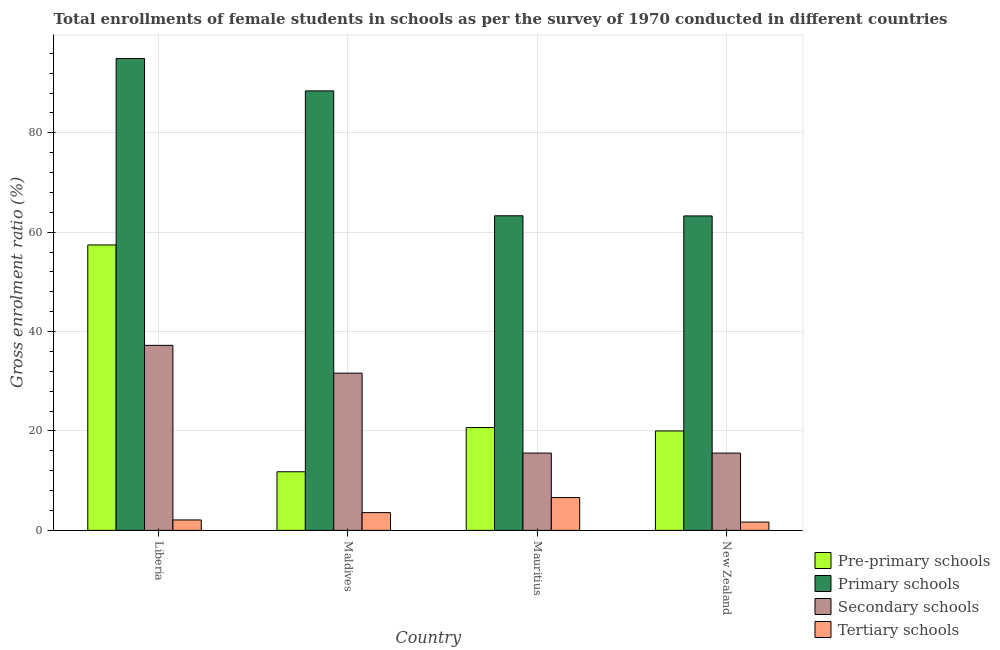How many groups of bars are there?
Your response must be concise. 4. How many bars are there on the 1st tick from the left?
Your response must be concise. 4. How many bars are there on the 3rd tick from the right?
Your answer should be very brief. 4. What is the label of the 4th group of bars from the left?
Provide a succinct answer. New Zealand. What is the gross enrolment ratio(female) in pre-primary schools in Liberia?
Ensure brevity in your answer.  57.43. Across all countries, what is the maximum gross enrolment ratio(female) in pre-primary schools?
Give a very brief answer. 57.43. Across all countries, what is the minimum gross enrolment ratio(female) in tertiary schools?
Your answer should be very brief. 1.67. In which country was the gross enrolment ratio(female) in primary schools maximum?
Your response must be concise. Liberia. In which country was the gross enrolment ratio(female) in pre-primary schools minimum?
Give a very brief answer. Maldives. What is the total gross enrolment ratio(female) in pre-primary schools in the graph?
Give a very brief answer. 109.93. What is the difference between the gross enrolment ratio(female) in tertiary schools in Liberia and that in Maldives?
Provide a short and direct response. -1.47. What is the difference between the gross enrolment ratio(female) in primary schools in New Zealand and the gross enrolment ratio(female) in secondary schools in Liberia?
Your answer should be compact. 26.04. What is the average gross enrolment ratio(female) in primary schools per country?
Give a very brief answer. 77.49. What is the difference between the gross enrolment ratio(female) in secondary schools and gross enrolment ratio(female) in primary schools in Maldives?
Your answer should be compact. -56.8. In how many countries, is the gross enrolment ratio(female) in tertiary schools greater than 28 %?
Your response must be concise. 0. What is the ratio of the gross enrolment ratio(female) in pre-primary schools in Liberia to that in Maldives?
Offer a terse response. 4.87. Is the gross enrolment ratio(female) in tertiary schools in Liberia less than that in New Zealand?
Offer a terse response. No. Is the difference between the gross enrolment ratio(female) in tertiary schools in Liberia and Maldives greater than the difference between the gross enrolment ratio(female) in pre-primary schools in Liberia and Maldives?
Ensure brevity in your answer.  No. What is the difference between the highest and the second highest gross enrolment ratio(female) in secondary schools?
Ensure brevity in your answer.  5.59. What is the difference between the highest and the lowest gross enrolment ratio(female) in secondary schools?
Give a very brief answer. 21.68. In how many countries, is the gross enrolment ratio(female) in tertiary schools greater than the average gross enrolment ratio(female) in tertiary schools taken over all countries?
Your answer should be compact. 2. What does the 3rd bar from the left in New Zealand represents?
Provide a short and direct response. Secondary schools. What does the 3rd bar from the right in Mauritius represents?
Ensure brevity in your answer.  Primary schools. Is it the case that in every country, the sum of the gross enrolment ratio(female) in pre-primary schools and gross enrolment ratio(female) in primary schools is greater than the gross enrolment ratio(female) in secondary schools?
Provide a short and direct response. Yes. How many bars are there?
Keep it short and to the point. 16. How many countries are there in the graph?
Your answer should be compact. 4. What is the difference between two consecutive major ticks on the Y-axis?
Offer a terse response. 20. Are the values on the major ticks of Y-axis written in scientific E-notation?
Your response must be concise. No. Where does the legend appear in the graph?
Ensure brevity in your answer.  Bottom right. How are the legend labels stacked?
Keep it short and to the point. Vertical. What is the title of the graph?
Provide a short and direct response. Total enrollments of female students in schools as per the survey of 1970 conducted in different countries. What is the label or title of the X-axis?
Your answer should be compact. Country. What is the Gross enrolment ratio (%) of Pre-primary schools in Liberia?
Your answer should be compact. 57.43. What is the Gross enrolment ratio (%) in Primary schools in Liberia?
Offer a very short reply. 94.95. What is the Gross enrolment ratio (%) of Secondary schools in Liberia?
Your response must be concise. 37.23. What is the Gross enrolment ratio (%) of Tertiary schools in Liberia?
Give a very brief answer. 2.1. What is the Gross enrolment ratio (%) in Pre-primary schools in Maldives?
Your answer should be compact. 11.8. What is the Gross enrolment ratio (%) in Primary schools in Maldives?
Offer a very short reply. 88.43. What is the Gross enrolment ratio (%) of Secondary schools in Maldives?
Make the answer very short. 31.64. What is the Gross enrolment ratio (%) of Tertiary schools in Maldives?
Offer a very short reply. 3.58. What is the Gross enrolment ratio (%) in Pre-primary schools in Mauritius?
Provide a succinct answer. 20.69. What is the Gross enrolment ratio (%) in Primary schools in Mauritius?
Your answer should be compact. 63.3. What is the Gross enrolment ratio (%) in Secondary schools in Mauritius?
Make the answer very short. 15.56. What is the Gross enrolment ratio (%) in Tertiary schools in Mauritius?
Your response must be concise. 6.6. What is the Gross enrolment ratio (%) of Pre-primary schools in New Zealand?
Ensure brevity in your answer.  20.01. What is the Gross enrolment ratio (%) in Primary schools in New Zealand?
Provide a succinct answer. 63.27. What is the Gross enrolment ratio (%) of Secondary schools in New Zealand?
Keep it short and to the point. 15.55. What is the Gross enrolment ratio (%) in Tertiary schools in New Zealand?
Your answer should be very brief. 1.67. Across all countries, what is the maximum Gross enrolment ratio (%) of Pre-primary schools?
Your answer should be compact. 57.43. Across all countries, what is the maximum Gross enrolment ratio (%) in Primary schools?
Your response must be concise. 94.95. Across all countries, what is the maximum Gross enrolment ratio (%) in Secondary schools?
Ensure brevity in your answer.  37.23. Across all countries, what is the maximum Gross enrolment ratio (%) of Tertiary schools?
Provide a succinct answer. 6.6. Across all countries, what is the minimum Gross enrolment ratio (%) of Pre-primary schools?
Ensure brevity in your answer.  11.8. Across all countries, what is the minimum Gross enrolment ratio (%) of Primary schools?
Provide a short and direct response. 63.27. Across all countries, what is the minimum Gross enrolment ratio (%) in Secondary schools?
Ensure brevity in your answer.  15.55. Across all countries, what is the minimum Gross enrolment ratio (%) in Tertiary schools?
Your answer should be compact. 1.67. What is the total Gross enrolment ratio (%) of Pre-primary schools in the graph?
Keep it short and to the point. 109.93. What is the total Gross enrolment ratio (%) in Primary schools in the graph?
Provide a succinct answer. 309.96. What is the total Gross enrolment ratio (%) of Secondary schools in the graph?
Your answer should be very brief. 99.98. What is the total Gross enrolment ratio (%) of Tertiary schools in the graph?
Offer a terse response. 13.95. What is the difference between the Gross enrolment ratio (%) of Pre-primary schools in Liberia and that in Maldives?
Keep it short and to the point. 45.63. What is the difference between the Gross enrolment ratio (%) in Primary schools in Liberia and that in Maldives?
Ensure brevity in your answer.  6.52. What is the difference between the Gross enrolment ratio (%) in Secondary schools in Liberia and that in Maldives?
Offer a very short reply. 5.59. What is the difference between the Gross enrolment ratio (%) of Tertiary schools in Liberia and that in Maldives?
Ensure brevity in your answer.  -1.47. What is the difference between the Gross enrolment ratio (%) in Pre-primary schools in Liberia and that in Mauritius?
Give a very brief answer. 36.74. What is the difference between the Gross enrolment ratio (%) of Primary schools in Liberia and that in Mauritius?
Ensure brevity in your answer.  31.65. What is the difference between the Gross enrolment ratio (%) in Secondary schools in Liberia and that in Mauritius?
Keep it short and to the point. 21.67. What is the difference between the Gross enrolment ratio (%) of Tertiary schools in Liberia and that in Mauritius?
Offer a terse response. -4.5. What is the difference between the Gross enrolment ratio (%) in Pre-primary schools in Liberia and that in New Zealand?
Offer a terse response. 37.42. What is the difference between the Gross enrolment ratio (%) of Primary schools in Liberia and that in New Zealand?
Your response must be concise. 31.68. What is the difference between the Gross enrolment ratio (%) in Secondary schools in Liberia and that in New Zealand?
Offer a very short reply. 21.68. What is the difference between the Gross enrolment ratio (%) in Tertiary schools in Liberia and that in New Zealand?
Keep it short and to the point. 0.44. What is the difference between the Gross enrolment ratio (%) in Pre-primary schools in Maldives and that in Mauritius?
Offer a terse response. -8.9. What is the difference between the Gross enrolment ratio (%) of Primary schools in Maldives and that in Mauritius?
Offer a very short reply. 25.13. What is the difference between the Gross enrolment ratio (%) of Secondary schools in Maldives and that in Mauritius?
Give a very brief answer. 16.08. What is the difference between the Gross enrolment ratio (%) in Tertiary schools in Maldives and that in Mauritius?
Offer a terse response. -3.03. What is the difference between the Gross enrolment ratio (%) of Pre-primary schools in Maldives and that in New Zealand?
Your answer should be very brief. -8.21. What is the difference between the Gross enrolment ratio (%) in Primary schools in Maldives and that in New Zealand?
Offer a very short reply. 25.16. What is the difference between the Gross enrolment ratio (%) of Secondary schools in Maldives and that in New Zealand?
Provide a short and direct response. 16.09. What is the difference between the Gross enrolment ratio (%) in Tertiary schools in Maldives and that in New Zealand?
Offer a terse response. 1.91. What is the difference between the Gross enrolment ratio (%) of Pre-primary schools in Mauritius and that in New Zealand?
Provide a succinct answer. 0.69. What is the difference between the Gross enrolment ratio (%) of Primary schools in Mauritius and that in New Zealand?
Offer a very short reply. 0.03. What is the difference between the Gross enrolment ratio (%) of Secondary schools in Mauritius and that in New Zealand?
Your answer should be very brief. 0.01. What is the difference between the Gross enrolment ratio (%) of Tertiary schools in Mauritius and that in New Zealand?
Offer a very short reply. 4.94. What is the difference between the Gross enrolment ratio (%) in Pre-primary schools in Liberia and the Gross enrolment ratio (%) in Primary schools in Maldives?
Give a very brief answer. -31. What is the difference between the Gross enrolment ratio (%) in Pre-primary schools in Liberia and the Gross enrolment ratio (%) in Secondary schools in Maldives?
Your answer should be compact. 25.8. What is the difference between the Gross enrolment ratio (%) in Pre-primary schools in Liberia and the Gross enrolment ratio (%) in Tertiary schools in Maldives?
Give a very brief answer. 53.86. What is the difference between the Gross enrolment ratio (%) in Primary schools in Liberia and the Gross enrolment ratio (%) in Secondary schools in Maldives?
Provide a succinct answer. 63.32. What is the difference between the Gross enrolment ratio (%) in Primary schools in Liberia and the Gross enrolment ratio (%) in Tertiary schools in Maldives?
Offer a terse response. 91.38. What is the difference between the Gross enrolment ratio (%) of Secondary schools in Liberia and the Gross enrolment ratio (%) of Tertiary schools in Maldives?
Your response must be concise. 33.66. What is the difference between the Gross enrolment ratio (%) of Pre-primary schools in Liberia and the Gross enrolment ratio (%) of Primary schools in Mauritius?
Your answer should be compact. -5.87. What is the difference between the Gross enrolment ratio (%) of Pre-primary schools in Liberia and the Gross enrolment ratio (%) of Secondary schools in Mauritius?
Your answer should be very brief. 41.87. What is the difference between the Gross enrolment ratio (%) in Pre-primary schools in Liberia and the Gross enrolment ratio (%) in Tertiary schools in Mauritius?
Your response must be concise. 50.83. What is the difference between the Gross enrolment ratio (%) in Primary schools in Liberia and the Gross enrolment ratio (%) in Secondary schools in Mauritius?
Provide a succinct answer. 79.4. What is the difference between the Gross enrolment ratio (%) of Primary schools in Liberia and the Gross enrolment ratio (%) of Tertiary schools in Mauritius?
Ensure brevity in your answer.  88.35. What is the difference between the Gross enrolment ratio (%) of Secondary schools in Liberia and the Gross enrolment ratio (%) of Tertiary schools in Mauritius?
Your answer should be very brief. 30.63. What is the difference between the Gross enrolment ratio (%) of Pre-primary schools in Liberia and the Gross enrolment ratio (%) of Primary schools in New Zealand?
Keep it short and to the point. -5.84. What is the difference between the Gross enrolment ratio (%) in Pre-primary schools in Liberia and the Gross enrolment ratio (%) in Secondary schools in New Zealand?
Make the answer very short. 41.88. What is the difference between the Gross enrolment ratio (%) of Pre-primary schools in Liberia and the Gross enrolment ratio (%) of Tertiary schools in New Zealand?
Provide a short and direct response. 55.77. What is the difference between the Gross enrolment ratio (%) in Primary schools in Liberia and the Gross enrolment ratio (%) in Secondary schools in New Zealand?
Keep it short and to the point. 79.4. What is the difference between the Gross enrolment ratio (%) in Primary schools in Liberia and the Gross enrolment ratio (%) in Tertiary schools in New Zealand?
Ensure brevity in your answer.  93.29. What is the difference between the Gross enrolment ratio (%) of Secondary schools in Liberia and the Gross enrolment ratio (%) of Tertiary schools in New Zealand?
Your response must be concise. 35.57. What is the difference between the Gross enrolment ratio (%) in Pre-primary schools in Maldives and the Gross enrolment ratio (%) in Primary schools in Mauritius?
Make the answer very short. -51.51. What is the difference between the Gross enrolment ratio (%) in Pre-primary schools in Maldives and the Gross enrolment ratio (%) in Secondary schools in Mauritius?
Ensure brevity in your answer.  -3.76. What is the difference between the Gross enrolment ratio (%) of Pre-primary schools in Maldives and the Gross enrolment ratio (%) of Tertiary schools in Mauritius?
Your response must be concise. 5.19. What is the difference between the Gross enrolment ratio (%) in Primary schools in Maldives and the Gross enrolment ratio (%) in Secondary schools in Mauritius?
Provide a succinct answer. 72.87. What is the difference between the Gross enrolment ratio (%) in Primary schools in Maldives and the Gross enrolment ratio (%) in Tertiary schools in Mauritius?
Offer a very short reply. 81.83. What is the difference between the Gross enrolment ratio (%) of Secondary schools in Maldives and the Gross enrolment ratio (%) of Tertiary schools in Mauritius?
Your answer should be compact. 25.03. What is the difference between the Gross enrolment ratio (%) in Pre-primary schools in Maldives and the Gross enrolment ratio (%) in Primary schools in New Zealand?
Your answer should be compact. -51.47. What is the difference between the Gross enrolment ratio (%) of Pre-primary schools in Maldives and the Gross enrolment ratio (%) of Secondary schools in New Zealand?
Give a very brief answer. -3.75. What is the difference between the Gross enrolment ratio (%) of Pre-primary schools in Maldives and the Gross enrolment ratio (%) of Tertiary schools in New Zealand?
Offer a terse response. 10.13. What is the difference between the Gross enrolment ratio (%) of Primary schools in Maldives and the Gross enrolment ratio (%) of Secondary schools in New Zealand?
Your answer should be compact. 72.88. What is the difference between the Gross enrolment ratio (%) of Primary schools in Maldives and the Gross enrolment ratio (%) of Tertiary schools in New Zealand?
Offer a very short reply. 86.77. What is the difference between the Gross enrolment ratio (%) in Secondary schools in Maldives and the Gross enrolment ratio (%) in Tertiary schools in New Zealand?
Your response must be concise. 29.97. What is the difference between the Gross enrolment ratio (%) in Pre-primary schools in Mauritius and the Gross enrolment ratio (%) in Primary schools in New Zealand?
Give a very brief answer. -42.58. What is the difference between the Gross enrolment ratio (%) of Pre-primary schools in Mauritius and the Gross enrolment ratio (%) of Secondary schools in New Zealand?
Your answer should be very brief. 5.14. What is the difference between the Gross enrolment ratio (%) of Pre-primary schools in Mauritius and the Gross enrolment ratio (%) of Tertiary schools in New Zealand?
Give a very brief answer. 19.03. What is the difference between the Gross enrolment ratio (%) of Primary schools in Mauritius and the Gross enrolment ratio (%) of Secondary schools in New Zealand?
Offer a very short reply. 47.75. What is the difference between the Gross enrolment ratio (%) of Primary schools in Mauritius and the Gross enrolment ratio (%) of Tertiary schools in New Zealand?
Make the answer very short. 61.64. What is the difference between the Gross enrolment ratio (%) of Secondary schools in Mauritius and the Gross enrolment ratio (%) of Tertiary schools in New Zealand?
Your answer should be very brief. 13.89. What is the average Gross enrolment ratio (%) in Pre-primary schools per country?
Offer a terse response. 27.48. What is the average Gross enrolment ratio (%) in Primary schools per country?
Keep it short and to the point. 77.49. What is the average Gross enrolment ratio (%) of Secondary schools per country?
Provide a succinct answer. 24.99. What is the average Gross enrolment ratio (%) in Tertiary schools per country?
Your response must be concise. 3.49. What is the difference between the Gross enrolment ratio (%) in Pre-primary schools and Gross enrolment ratio (%) in Primary schools in Liberia?
Ensure brevity in your answer.  -37.52. What is the difference between the Gross enrolment ratio (%) of Pre-primary schools and Gross enrolment ratio (%) of Secondary schools in Liberia?
Your answer should be very brief. 20.2. What is the difference between the Gross enrolment ratio (%) of Pre-primary schools and Gross enrolment ratio (%) of Tertiary schools in Liberia?
Offer a very short reply. 55.33. What is the difference between the Gross enrolment ratio (%) in Primary schools and Gross enrolment ratio (%) in Secondary schools in Liberia?
Give a very brief answer. 57.72. What is the difference between the Gross enrolment ratio (%) in Primary schools and Gross enrolment ratio (%) in Tertiary schools in Liberia?
Make the answer very short. 92.85. What is the difference between the Gross enrolment ratio (%) of Secondary schools and Gross enrolment ratio (%) of Tertiary schools in Liberia?
Provide a short and direct response. 35.13. What is the difference between the Gross enrolment ratio (%) in Pre-primary schools and Gross enrolment ratio (%) in Primary schools in Maldives?
Your answer should be compact. -76.63. What is the difference between the Gross enrolment ratio (%) in Pre-primary schools and Gross enrolment ratio (%) in Secondary schools in Maldives?
Provide a succinct answer. -19.84. What is the difference between the Gross enrolment ratio (%) in Pre-primary schools and Gross enrolment ratio (%) in Tertiary schools in Maldives?
Provide a succinct answer. 8.22. What is the difference between the Gross enrolment ratio (%) of Primary schools and Gross enrolment ratio (%) of Secondary schools in Maldives?
Provide a succinct answer. 56.8. What is the difference between the Gross enrolment ratio (%) in Primary schools and Gross enrolment ratio (%) in Tertiary schools in Maldives?
Offer a terse response. 84.86. What is the difference between the Gross enrolment ratio (%) of Secondary schools and Gross enrolment ratio (%) of Tertiary schools in Maldives?
Give a very brief answer. 28.06. What is the difference between the Gross enrolment ratio (%) of Pre-primary schools and Gross enrolment ratio (%) of Primary schools in Mauritius?
Provide a short and direct response. -42.61. What is the difference between the Gross enrolment ratio (%) in Pre-primary schools and Gross enrolment ratio (%) in Secondary schools in Mauritius?
Your answer should be compact. 5.14. What is the difference between the Gross enrolment ratio (%) in Pre-primary schools and Gross enrolment ratio (%) in Tertiary schools in Mauritius?
Your answer should be very brief. 14.09. What is the difference between the Gross enrolment ratio (%) of Primary schools and Gross enrolment ratio (%) of Secondary schools in Mauritius?
Give a very brief answer. 47.75. What is the difference between the Gross enrolment ratio (%) of Primary schools and Gross enrolment ratio (%) of Tertiary schools in Mauritius?
Your response must be concise. 56.7. What is the difference between the Gross enrolment ratio (%) in Secondary schools and Gross enrolment ratio (%) in Tertiary schools in Mauritius?
Ensure brevity in your answer.  8.95. What is the difference between the Gross enrolment ratio (%) of Pre-primary schools and Gross enrolment ratio (%) of Primary schools in New Zealand?
Your response must be concise. -43.26. What is the difference between the Gross enrolment ratio (%) of Pre-primary schools and Gross enrolment ratio (%) of Secondary schools in New Zealand?
Keep it short and to the point. 4.46. What is the difference between the Gross enrolment ratio (%) in Pre-primary schools and Gross enrolment ratio (%) in Tertiary schools in New Zealand?
Offer a terse response. 18.34. What is the difference between the Gross enrolment ratio (%) in Primary schools and Gross enrolment ratio (%) in Secondary schools in New Zealand?
Make the answer very short. 47.72. What is the difference between the Gross enrolment ratio (%) of Primary schools and Gross enrolment ratio (%) of Tertiary schools in New Zealand?
Your response must be concise. 61.6. What is the difference between the Gross enrolment ratio (%) in Secondary schools and Gross enrolment ratio (%) in Tertiary schools in New Zealand?
Your answer should be compact. 13.88. What is the ratio of the Gross enrolment ratio (%) of Pre-primary schools in Liberia to that in Maldives?
Give a very brief answer. 4.87. What is the ratio of the Gross enrolment ratio (%) in Primary schools in Liberia to that in Maldives?
Keep it short and to the point. 1.07. What is the ratio of the Gross enrolment ratio (%) in Secondary schools in Liberia to that in Maldives?
Offer a very short reply. 1.18. What is the ratio of the Gross enrolment ratio (%) in Tertiary schools in Liberia to that in Maldives?
Ensure brevity in your answer.  0.59. What is the ratio of the Gross enrolment ratio (%) in Pre-primary schools in Liberia to that in Mauritius?
Keep it short and to the point. 2.78. What is the ratio of the Gross enrolment ratio (%) in Primary schools in Liberia to that in Mauritius?
Your response must be concise. 1.5. What is the ratio of the Gross enrolment ratio (%) in Secondary schools in Liberia to that in Mauritius?
Your answer should be very brief. 2.39. What is the ratio of the Gross enrolment ratio (%) in Tertiary schools in Liberia to that in Mauritius?
Make the answer very short. 0.32. What is the ratio of the Gross enrolment ratio (%) of Pre-primary schools in Liberia to that in New Zealand?
Provide a succinct answer. 2.87. What is the ratio of the Gross enrolment ratio (%) of Primary schools in Liberia to that in New Zealand?
Your answer should be very brief. 1.5. What is the ratio of the Gross enrolment ratio (%) of Secondary schools in Liberia to that in New Zealand?
Offer a terse response. 2.39. What is the ratio of the Gross enrolment ratio (%) of Tertiary schools in Liberia to that in New Zealand?
Ensure brevity in your answer.  1.26. What is the ratio of the Gross enrolment ratio (%) of Pre-primary schools in Maldives to that in Mauritius?
Your answer should be very brief. 0.57. What is the ratio of the Gross enrolment ratio (%) of Primary schools in Maldives to that in Mauritius?
Provide a succinct answer. 1.4. What is the ratio of the Gross enrolment ratio (%) of Secondary schools in Maldives to that in Mauritius?
Offer a terse response. 2.03. What is the ratio of the Gross enrolment ratio (%) of Tertiary schools in Maldives to that in Mauritius?
Offer a terse response. 0.54. What is the ratio of the Gross enrolment ratio (%) in Pre-primary schools in Maldives to that in New Zealand?
Give a very brief answer. 0.59. What is the ratio of the Gross enrolment ratio (%) of Primary schools in Maldives to that in New Zealand?
Your response must be concise. 1.4. What is the ratio of the Gross enrolment ratio (%) in Secondary schools in Maldives to that in New Zealand?
Offer a very short reply. 2.03. What is the ratio of the Gross enrolment ratio (%) in Tertiary schools in Maldives to that in New Zealand?
Keep it short and to the point. 2.15. What is the ratio of the Gross enrolment ratio (%) in Pre-primary schools in Mauritius to that in New Zealand?
Make the answer very short. 1.03. What is the ratio of the Gross enrolment ratio (%) of Tertiary schools in Mauritius to that in New Zealand?
Your response must be concise. 3.96. What is the difference between the highest and the second highest Gross enrolment ratio (%) in Pre-primary schools?
Keep it short and to the point. 36.74. What is the difference between the highest and the second highest Gross enrolment ratio (%) of Primary schools?
Ensure brevity in your answer.  6.52. What is the difference between the highest and the second highest Gross enrolment ratio (%) in Secondary schools?
Provide a short and direct response. 5.59. What is the difference between the highest and the second highest Gross enrolment ratio (%) in Tertiary schools?
Provide a succinct answer. 3.03. What is the difference between the highest and the lowest Gross enrolment ratio (%) in Pre-primary schools?
Provide a succinct answer. 45.63. What is the difference between the highest and the lowest Gross enrolment ratio (%) of Primary schools?
Make the answer very short. 31.68. What is the difference between the highest and the lowest Gross enrolment ratio (%) of Secondary schools?
Provide a short and direct response. 21.68. What is the difference between the highest and the lowest Gross enrolment ratio (%) of Tertiary schools?
Give a very brief answer. 4.94. 